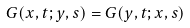Convert formula to latex. <formula><loc_0><loc_0><loc_500><loc_500>G ( x , t ; y , s ) = G ( y , t ; x , s )</formula> 